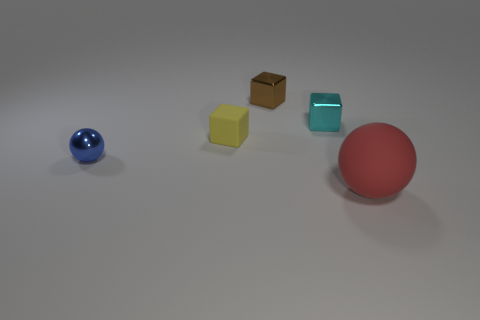Add 1 brown blocks. How many objects exist? 6 Subtract all balls. How many objects are left? 3 Subtract 0 gray spheres. How many objects are left? 5 Subtract all red matte cylinders. Subtract all matte objects. How many objects are left? 3 Add 1 small brown blocks. How many small brown blocks are left? 2 Add 5 tiny metallic spheres. How many tiny metallic spheres exist? 6 